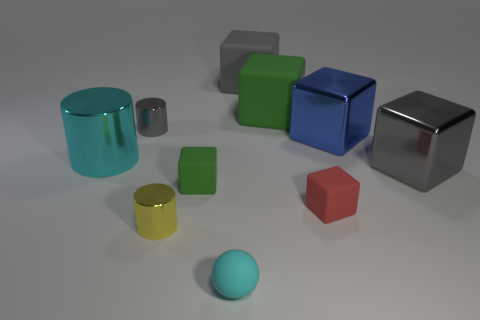Subtract 3 cubes. How many cubes are left? 3 Subtract all red blocks. How many blocks are left? 5 Subtract all large gray matte cubes. How many cubes are left? 5 Subtract all brown cubes. Subtract all yellow cylinders. How many cubes are left? 6 Subtract all cylinders. How many objects are left? 7 Add 9 big gray shiny objects. How many big gray shiny objects are left? 10 Add 4 matte balls. How many matte balls exist? 5 Subtract 0 green spheres. How many objects are left? 10 Subtract all red rubber objects. Subtract all blue things. How many objects are left? 8 